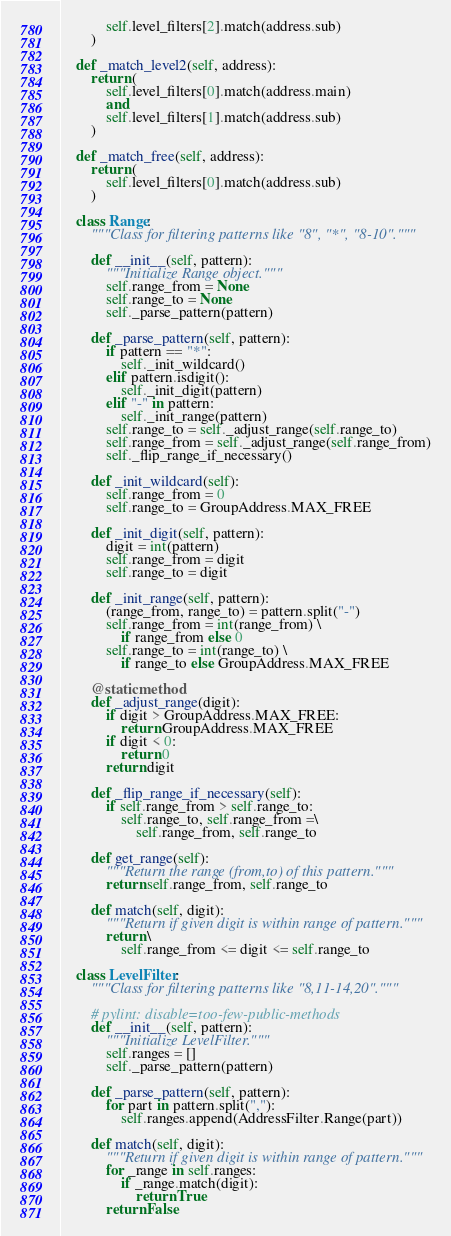<code> <loc_0><loc_0><loc_500><loc_500><_Python_>            self.level_filters[2].match(address.sub)
        )

    def _match_level2(self, address):
        return (
            self.level_filters[0].match(address.main)
            and
            self.level_filters[1].match(address.sub)
        )

    def _match_free(self, address):
        return (
            self.level_filters[0].match(address.sub)
        )

    class Range:
        """Class for filtering patterns like "8", "*", "8-10"."""

        def __init__(self, pattern):
            """Initialize Range object."""
            self.range_from = None
            self.range_to = None
            self._parse_pattern(pattern)

        def _parse_pattern(self, pattern):
            if pattern == "*":
                self._init_wildcard()
            elif pattern.isdigit():
                self._init_digit(pattern)
            elif "-" in pattern:
                self._init_range(pattern)
            self.range_to = self._adjust_range(self.range_to)
            self.range_from = self._adjust_range(self.range_from)
            self._flip_range_if_necessary()

        def _init_wildcard(self):
            self.range_from = 0
            self.range_to = GroupAddress.MAX_FREE

        def _init_digit(self, pattern):
            digit = int(pattern)
            self.range_from = digit
            self.range_to = digit

        def _init_range(self, pattern):
            (range_from, range_to) = pattern.split("-")
            self.range_from = int(range_from) \
                if range_from else 0
            self.range_to = int(range_to) \
                if range_to else GroupAddress.MAX_FREE

        @staticmethod
        def _adjust_range(digit):
            if digit > GroupAddress.MAX_FREE:
                return GroupAddress.MAX_FREE
            if digit < 0:
                return 0
            return digit

        def _flip_range_if_necessary(self):
            if self.range_from > self.range_to:
                self.range_to, self.range_from =\
                    self.range_from, self.range_to

        def get_range(self):
            """Return the range (from,to) of this pattern."""
            return self.range_from, self.range_to

        def match(self, digit):
            """Return if given digit is within range of pattern."""
            return \
                self.range_from <= digit <= self.range_to

    class LevelFilter:
        """Class for filtering patterns like "8,11-14,20"."""

        # pylint: disable=too-few-public-methods
        def __init__(self, pattern):
            """Initialize LevelFilter."""
            self.ranges = []
            self._parse_pattern(pattern)

        def _parse_pattern(self, pattern):
            for part in pattern.split(","):
                self.ranges.append(AddressFilter.Range(part))

        def match(self, digit):
            """Return if given digit is within range of pattern."""
            for _range in self.ranges:
                if _range.match(digit):
                    return True
            return False
</code> 